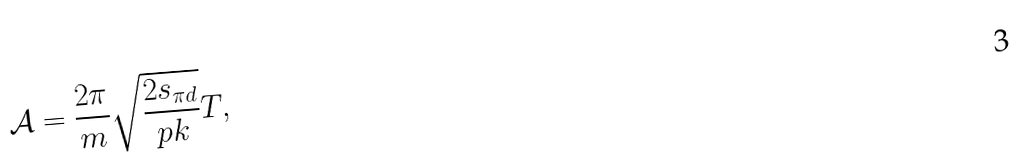Convert formula to latex. <formula><loc_0><loc_0><loc_500><loc_500>\mathcal { A } = \frac { 2 \pi } { m } \sqrt { \frac { 2 s _ { \pi { d } } } { p k } } T ,</formula> 